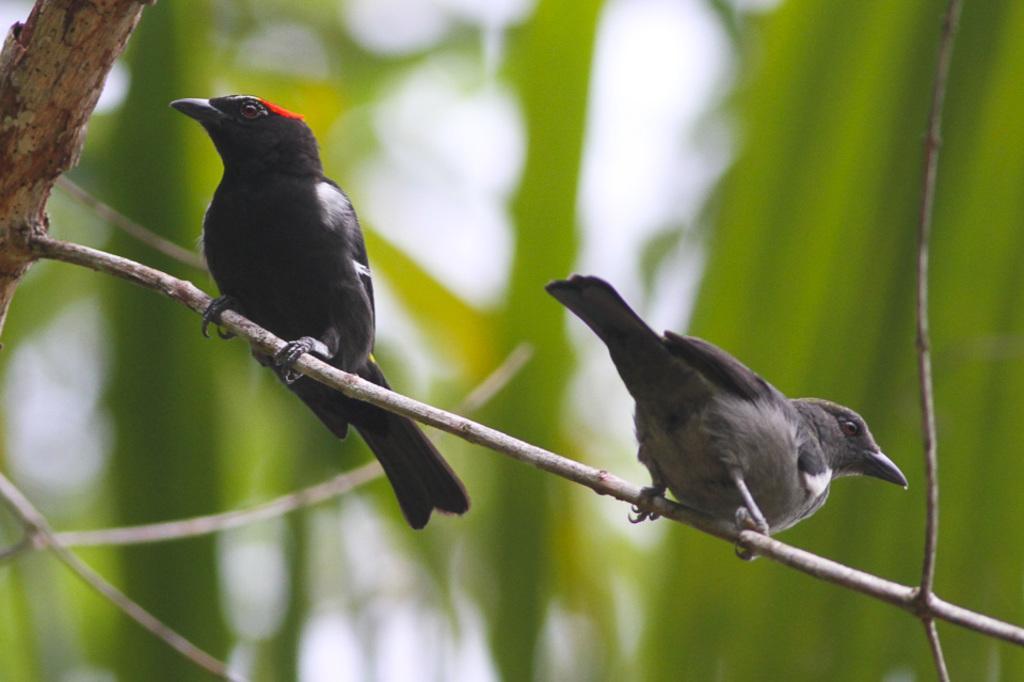How would you summarize this image in a sentence or two? This picture is clicked outside. In the center we can see the two birds standing on the stem of a tree. The background of the image is blur and we can see the green color objects in the background. 